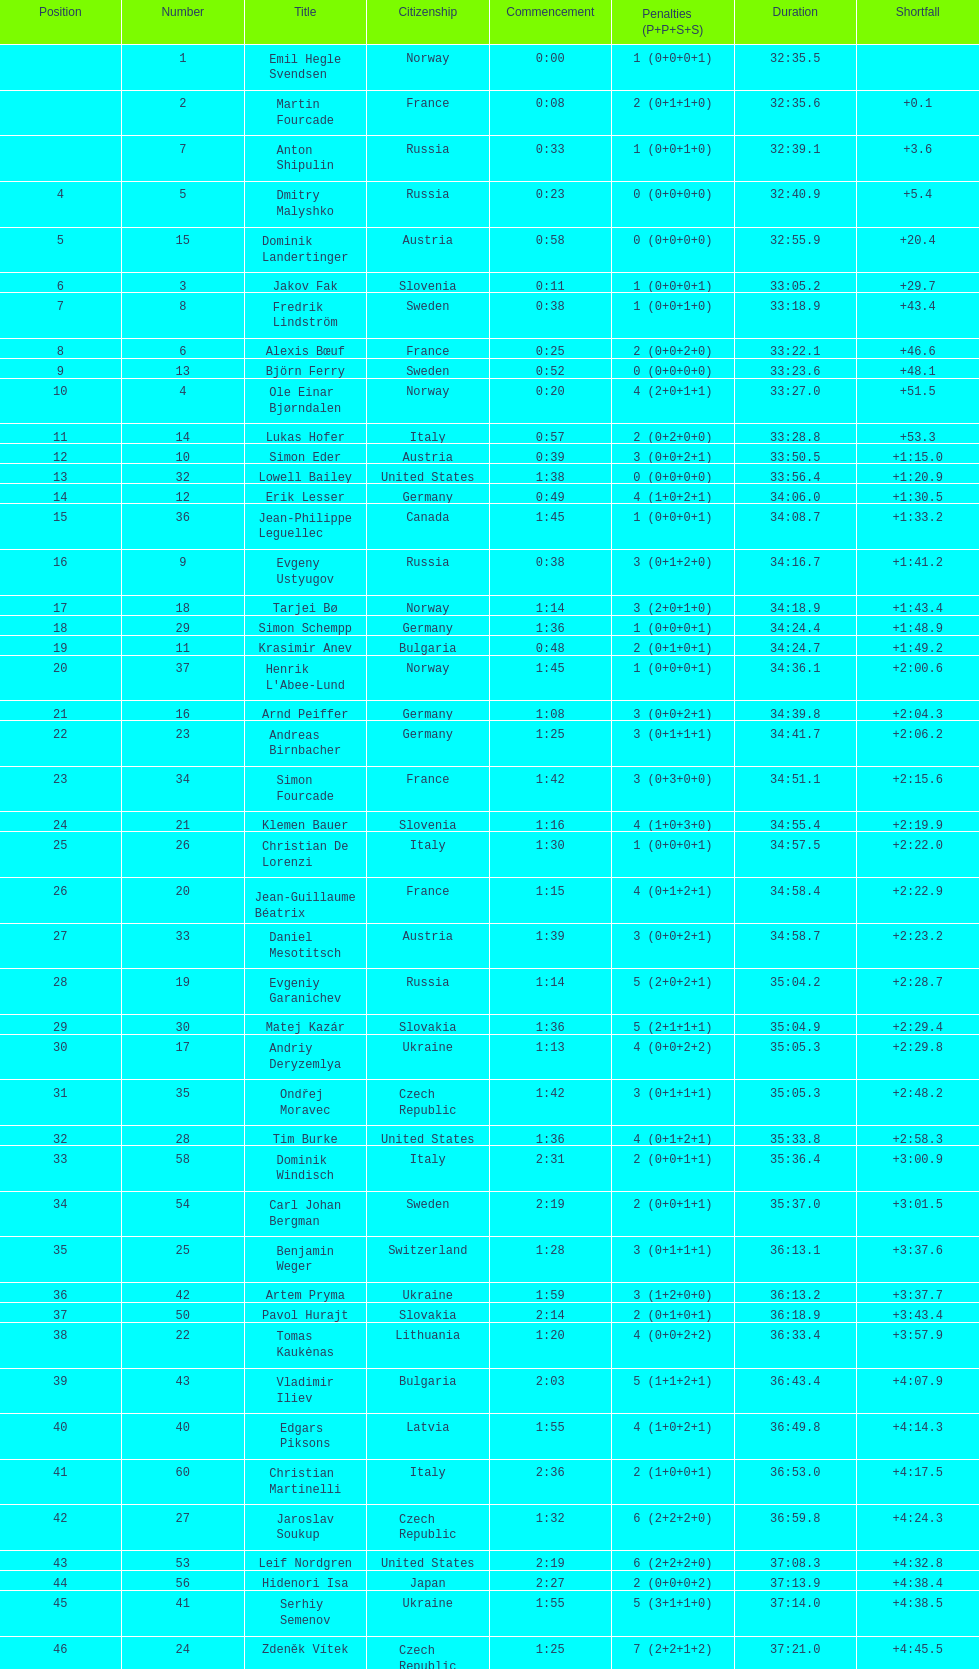Between bjorn ferry, simon elder and erik lesser - who had the most penalties? Erik Lesser. 